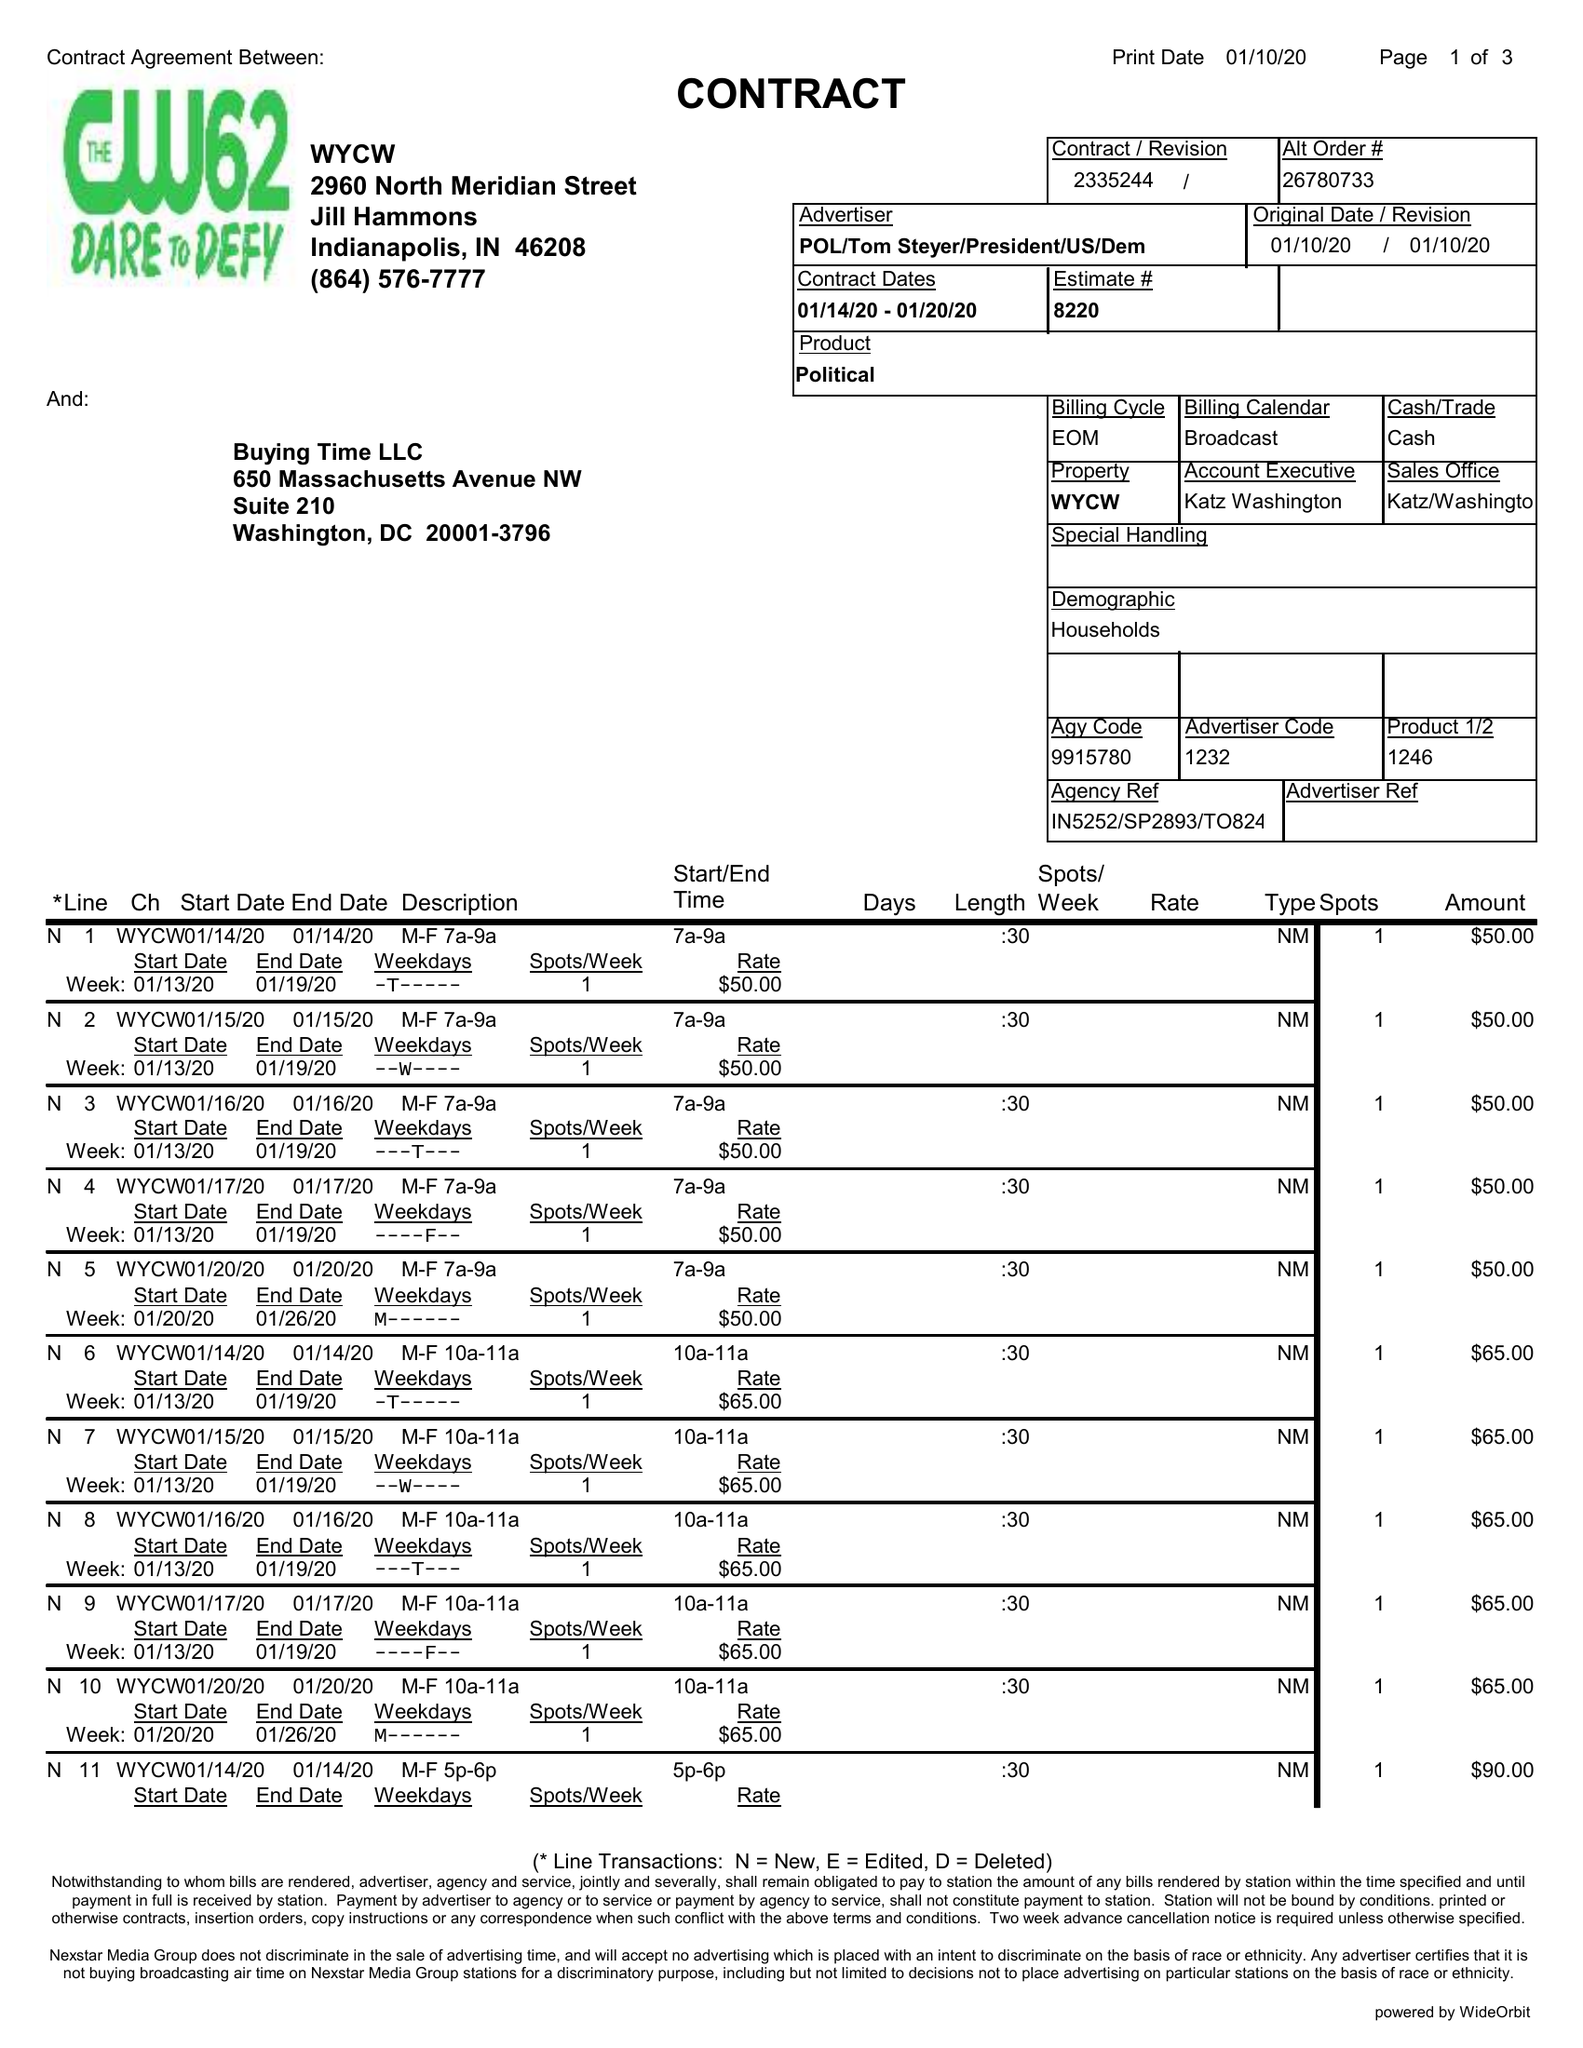What is the value for the gross_amount?
Answer the question using a single word or phrase. 2930.00 